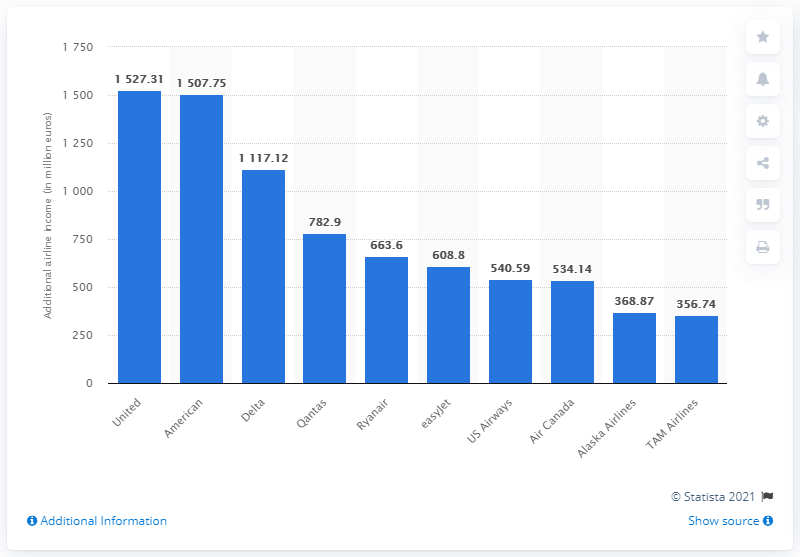Point out several critical features in this image. In 2009, Ryanair generated a significant amount of revenue from ancillary services, with a total of 663.6... 